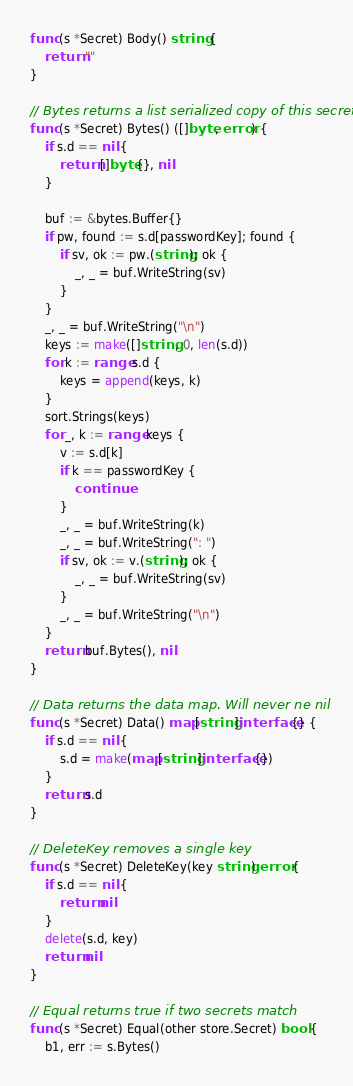<code> <loc_0><loc_0><loc_500><loc_500><_Go_>func (s *Secret) Body() string {
	return ""
}

// Bytes returns a list serialized copy of this secret
func (s *Secret) Bytes() ([]byte, error) {
	if s.d == nil {
		return []byte{}, nil
	}

	buf := &bytes.Buffer{}
	if pw, found := s.d[passwordKey]; found {
		if sv, ok := pw.(string); ok {
			_, _ = buf.WriteString(sv)
		}
	}
	_, _ = buf.WriteString("\n")
	keys := make([]string, 0, len(s.d))
	for k := range s.d {
		keys = append(keys, k)
	}
	sort.Strings(keys)
	for _, k := range keys {
		v := s.d[k]
		if k == passwordKey {
			continue
		}
		_, _ = buf.WriteString(k)
		_, _ = buf.WriteString(": ")
		if sv, ok := v.(string); ok {
			_, _ = buf.WriteString(sv)
		}
		_, _ = buf.WriteString("\n")
	}
	return buf.Bytes(), nil
}

// Data returns the data map. Will never ne nil
func (s *Secret) Data() map[string]interface{} {
	if s.d == nil {
		s.d = make(map[string]interface{})
	}
	return s.d
}

// DeleteKey removes a single key
func (s *Secret) DeleteKey(key string) error {
	if s.d == nil {
		return nil
	}
	delete(s.d, key)
	return nil
}

// Equal returns true if two secrets match
func (s *Secret) Equal(other store.Secret) bool {
	b1, err := s.Bytes()</code> 